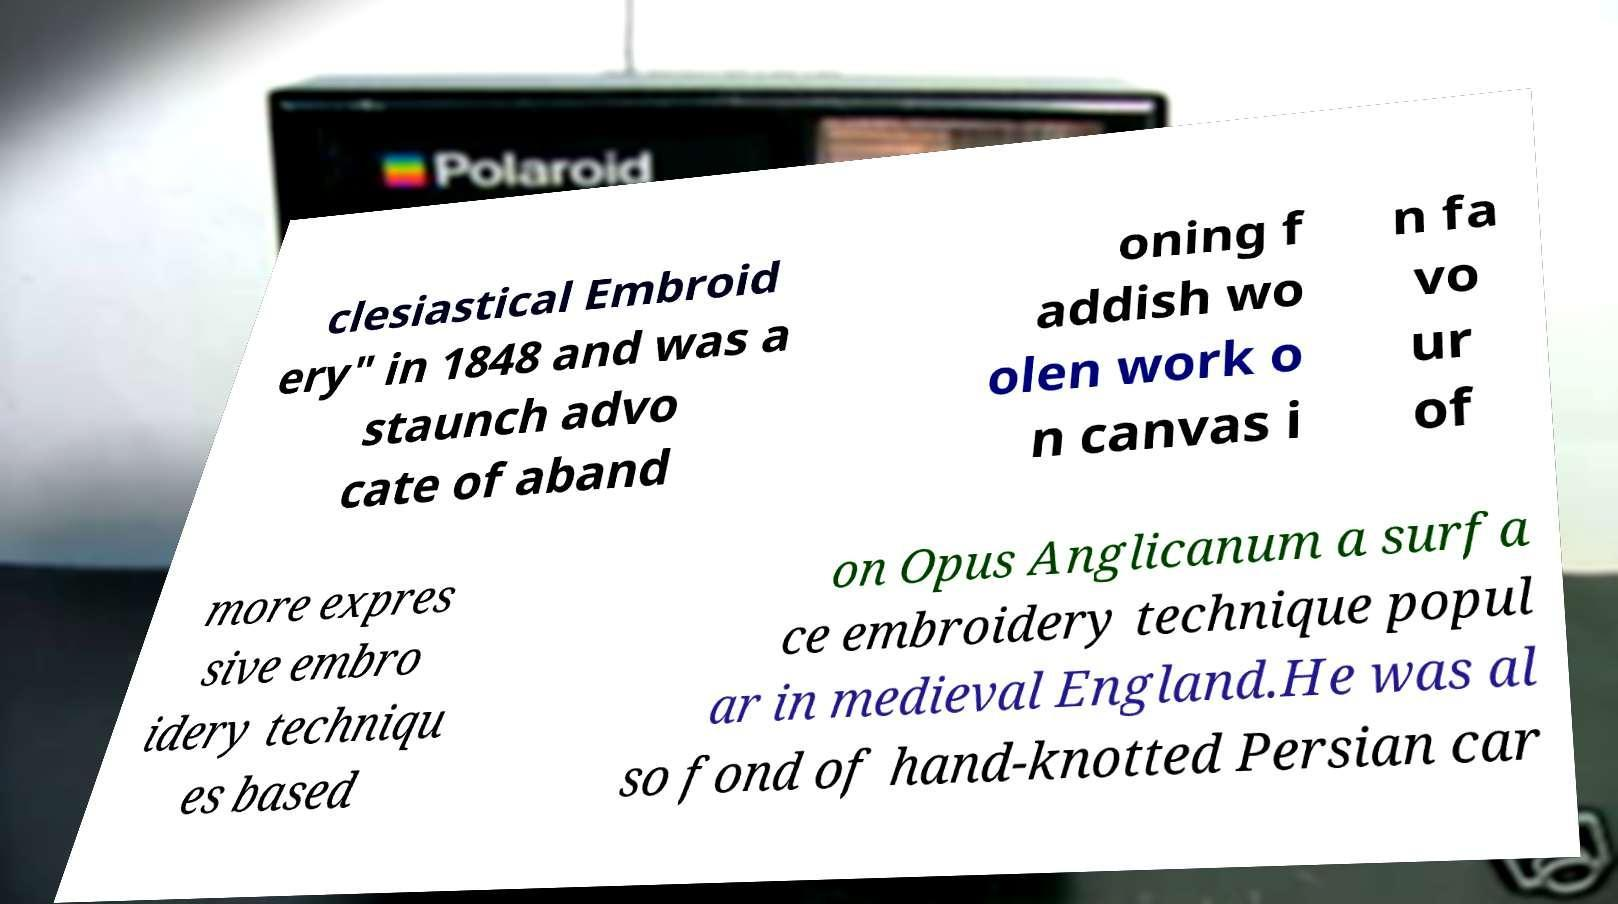There's text embedded in this image that I need extracted. Can you transcribe it verbatim? clesiastical Embroid ery" in 1848 and was a staunch advo cate of aband oning f addish wo olen work o n canvas i n fa vo ur of more expres sive embro idery techniqu es based on Opus Anglicanum a surfa ce embroidery technique popul ar in medieval England.He was al so fond of hand-knotted Persian car 